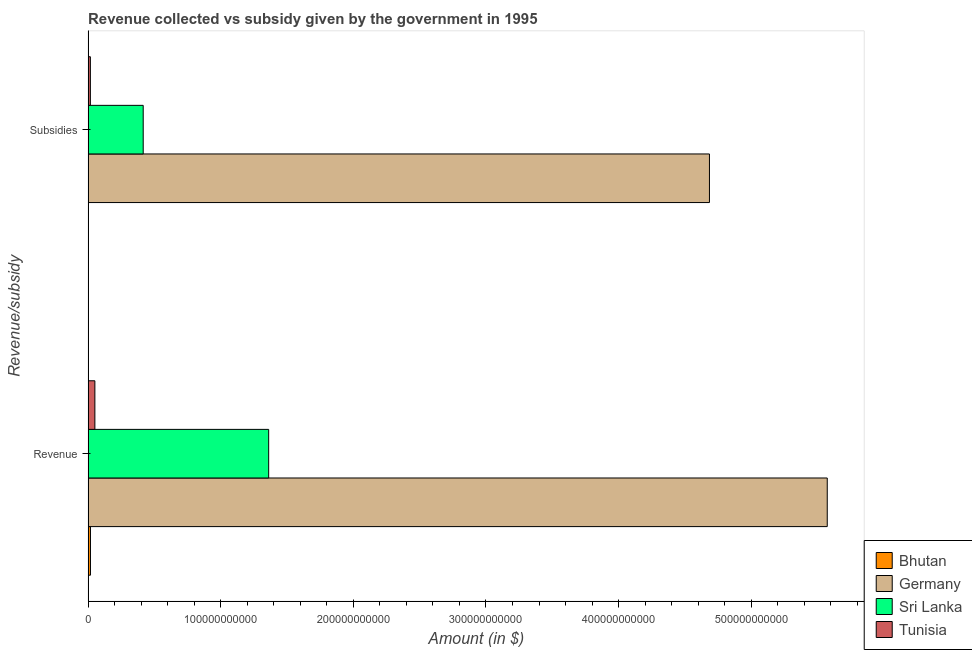How many groups of bars are there?
Your answer should be very brief. 2. Are the number of bars per tick equal to the number of legend labels?
Offer a terse response. Yes. How many bars are there on the 2nd tick from the top?
Provide a short and direct response. 4. What is the label of the 2nd group of bars from the top?
Your answer should be very brief. Revenue. What is the amount of subsidies given in Sri Lanka?
Make the answer very short. 4.16e+1. Across all countries, what is the maximum amount of revenue collected?
Offer a terse response. 5.57e+11. Across all countries, what is the minimum amount of revenue collected?
Provide a succinct answer. 1.79e+09. In which country was the amount of revenue collected maximum?
Offer a very short reply. Germany. In which country was the amount of revenue collected minimum?
Your answer should be very brief. Bhutan. What is the total amount of revenue collected in the graph?
Your answer should be very brief. 7.00e+11. What is the difference between the amount of revenue collected in Bhutan and that in Sri Lanka?
Offer a very short reply. -1.34e+11. What is the difference between the amount of revenue collected in Germany and the amount of subsidies given in Bhutan?
Provide a succinct answer. 5.57e+11. What is the average amount of revenue collected per country?
Offer a terse response. 1.75e+11. What is the difference between the amount of revenue collected and amount of subsidies given in Germany?
Give a very brief answer. 8.88e+1. What is the ratio of the amount of subsidies given in Tunisia to that in Bhutan?
Provide a succinct answer. 5.76. What does the 4th bar from the top in Revenue represents?
Offer a terse response. Bhutan. What does the 3rd bar from the bottom in Subsidies represents?
Your answer should be compact. Sri Lanka. What is the difference between two consecutive major ticks on the X-axis?
Give a very brief answer. 1.00e+11. Are the values on the major ticks of X-axis written in scientific E-notation?
Make the answer very short. No. Does the graph contain grids?
Give a very brief answer. No. Where does the legend appear in the graph?
Provide a succinct answer. Bottom right. How are the legend labels stacked?
Offer a terse response. Vertical. What is the title of the graph?
Ensure brevity in your answer.  Revenue collected vs subsidy given by the government in 1995. What is the label or title of the X-axis?
Offer a very short reply. Amount (in $). What is the label or title of the Y-axis?
Offer a very short reply. Revenue/subsidy. What is the Amount (in $) in Bhutan in Revenue?
Your response must be concise. 1.79e+09. What is the Amount (in $) of Germany in Revenue?
Provide a short and direct response. 5.57e+11. What is the Amount (in $) in Sri Lanka in Revenue?
Make the answer very short. 1.36e+11. What is the Amount (in $) of Tunisia in Revenue?
Keep it short and to the point. 5.12e+09. What is the Amount (in $) in Bhutan in Subsidies?
Give a very brief answer. 2.99e+08. What is the Amount (in $) of Germany in Subsidies?
Offer a very short reply. 4.69e+11. What is the Amount (in $) in Sri Lanka in Subsidies?
Ensure brevity in your answer.  4.16e+1. What is the Amount (in $) in Tunisia in Subsidies?
Keep it short and to the point. 1.72e+09. Across all Revenue/subsidy, what is the maximum Amount (in $) of Bhutan?
Your answer should be very brief. 1.79e+09. Across all Revenue/subsidy, what is the maximum Amount (in $) of Germany?
Offer a very short reply. 5.57e+11. Across all Revenue/subsidy, what is the maximum Amount (in $) of Sri Lanka?
Give a very brief answer. 1.36e+11. Across all Revenue/subsidy, what is the maximum Amount (in $) of Tunisia?
Provide a succinct answer. 5.12e+09. Across all Revenue/subsidy, what is the minimum Amount (in $) of Bhutan?
Provide a short and direct response. 2.99e+08. Across all Revenue/subsidy, what is the minimum Amount (in $) in Germany?
Your answer should be compact. 4.69e+11. Across all Revenue/subsidy, what is the minimum Amount (in $) in Sri Lanka?
Provide a short and direct response. 4.16e+1. Across all Revenue/subsidy, what is the minimum Amount (in $) of Tunisia?
Offer a very short reply. 1.72e+09. What is the total Amount (in $) of Bhutan in the graph?
Make the answer very short. 2.09e+09. What is the total Amount (in $) of Germany in the graph?
Your answer should be compact. 1.03e+12. What is the total Amount (in $) of Sri Lanka in the graph?
Offer a very short reply. 1.78e+11. What is the total Amount (in $) in Tunisia in the graph?
Your answer should be very brief. 6.84e+09. What is the difference between the Amount (in $) in Bhutan in Revenue and that in Subsidies?
Ensure brevity in your answer.  1.49e+09. What is the difference between the Amount (in $) of Germany in Revenue and that in Subsidies?
Offer a terse response. 8.88e+1. What is the difference between the Amount (in $) of Sri Lanka in Revenue and that in Subsidies?
Give a very brief answer. 9.46e+1. What is the difference between the Amount (in $) in Tunisia in Revenue and that in Subsidies?
Offer a terse response. 3.40e+09. What is the difference between the Amount (in $) of Bhutan in Revenue and the Amount (in $) of Germany in Subsidies?
Provide a succinct answer. -4.67e+11. What is the difference between the Amount (in $) in Bhutan in Revenue and the Amount (in $) in Sri Lanka in Subsidies?
Make the answer very short. -3.98e+1. What is the difference between the Amount (in $) of Bhutan in Revenue and the Amount (in $) of Tunisia in Subsidies?
Provide a short and direct response. 6.97e+07. What is the difference between the Amount (in $) of Germany in Revenue and the Amount (in $) of Sri Lanka in Subsidies?
Provide a succinct answer. 5.16e+11. What is the difference between the Amount (in $) in Germany in Revenue and the Amount (in $) in Tunisia in Subsidies?
Make the answer very short. 5.56e+11. What is the difference between the Amount (in $) of Sri Lanka in Revenue and the Amount (in $) of Tunisia in Subsidies?
Your answer should be compact. 1.34e+11. What is the average Amount (in $) in Bhutan per Revenue/subsidy?
Provide a succinct answer. 1.04e+09. What is the average Amount (in $) of Germany per Revenue/subsidy?
Give a very brief answer. 5.13e+11. What is the average Amount (in $) in Sri Lanka per Revenue/subsidy?
Provide a short and direct response. 8.89e+1. What is the average Amount (in $) of Tunisia per Revenue/subsidy?
Give a very brief answer. 3.42e+09. What is the difference between the Amount (in $) of Bhutan and Amount (in $) of Germany in Revenue?
Your answer should be very brief. -5.56e+11. What is the difference between the Amount (in $) of Bhutan and Amount (in $) of Sri Lanka in Revenue?
Keep it short and to the point. -1.34e+11. What is the difference between the Amount (in $) of Bhutan and Amount (in $) of Tunisia in Revenue?
Your response must be concise. -3.33e+09. What is the difference between the Amount (in $) in Germany and Amount (in $) in Sri Lanka in Revenue?
Your answer should be very brief. 4.21e+11. What is the difference between the Amount (in $) of Germany and Amount (in $) of Tunisia in Revenue?
Your response must be concise. 5.52e+11. What is the difference between the Amount (in $) of Sri Lanka and Amount (in $) of Tunisia in Revenue?
Make the answer very short. 1.31e+11. What is the difference between the Amount (in $) of Bhutan and Amount (in $) of Germany in Subsidies?
Your answer should be compact. -4.68e+11. What is the difference between the Amount (in $) in Bhutan and Amount (in $) in Sri Lanka in Subsidies?
Your response must be concise. -4.13e+1. What is the difference between the Amount (in $) in Bhutan and Amount (in $) in Tunisia in Subsidies?
Offer a very short reply. -1.42e+09. What is the difference between the Amount (in $) in Germany and Amount (in $) in Sri Lanka in Subsidies?
Provide a short and direct response. 4.27e+11. What is the difference between the Amount (in $) in Germany and Amount (in $) in Tunisia in Subsidies?
Offer a very short reply. 4.67e+11. What is the difference between the Amount (in $) in Sri Lanka and Amount (in $) in Tunisia in Subsidies?
Make the answer very short. 3.98e+1. What is the ratio of the Amount (in $) in Bhutan in Revenue to that in Subsidies?
Your answer should be very brief. 5.99. What is the ratio of the Amount (in $) of Germany in Revenue to that in Subsidies?
Provide a succinct answer. 1.19. What is the ratio of the Amount (in $) in Sri Lanka in Revenue to that in Subsidies?
Provide a succinct answer. 3.28. What is the ratio of the Amount (in $) in Tunisia in Revenue to that in Subsidies?
Your response must be concise. 2.97. What is the difference between the highest and the second highest Amount (in $) in Bhutan?
Ensure brevity in your answer.  1.49e+09. What is the difference between the highest and the second highest Amount (in $) in Germany?
Your answer should be compact. 8.88e+1. What is the difference between the highest and the second highest Amount (in $) in Sri Lanka?
Your answer should be compact. 9.46e+1. What is the difference between the highest and the second highest Amount (in $) of Tunisia?
Provide a succinct answer. 3.40e+09. What is the difference between the highest and the lowest Amount (in $) of Bhutan?
Your answer should be compact. 1.49e+09. What is the difference between the highest and the lowest Amount (in $) of Germany?
Give a very brief answer. 8.88e+1. What is the difference between the highest and the lowest Amount (in $) in Sri Lanka?
Make the answer very short. 9.46e+1. What is the difference between the highest and the lowest Amount (in $) of Tunisia?
Ensure brevity in your answer.  3.40e+09. 